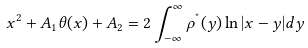Convert formula to latex. <formula><loc_0><loc_0><loc_500><loc_500>x ^ { 2 } + A _ { 1 } \theta ( x ) + A _ { 2 } = 2 \int _ { - \infty } ^ { \infty } \rho ^ { ^ { * } } ( y ) \ln | x - y | d y</formula> 